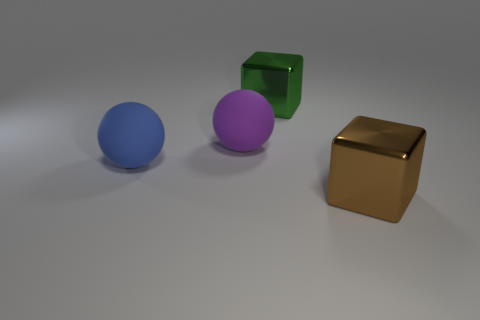Add 4 blue rubber blocks. How many objects exist? 8 Subtract all green things. Subtract all large metallic things. How many objects are left? 1 Add 4 big shiny cubes. How many big shiny cubes are left? 6 Add 4 big purple objects. How many big purple objects exist? 5 Subtract 1 purple spheres. How many objects are left? 3 Subtract all purple balls. Subtract all green cylinders. How many balls are left? 1 